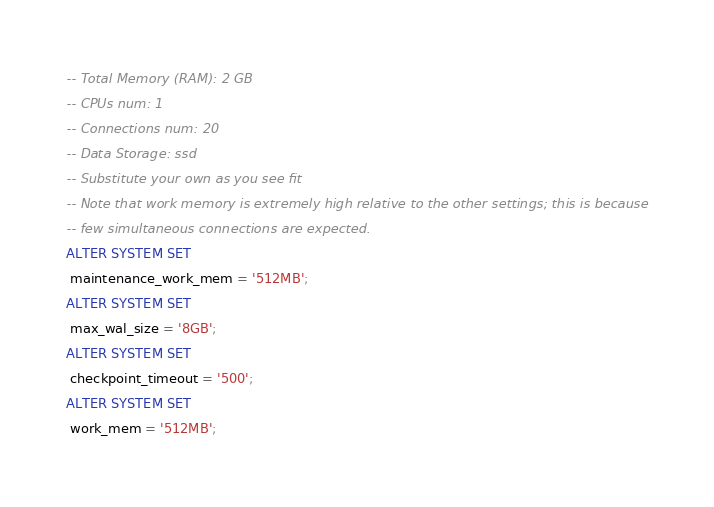<code> <loc_0><loc_0><loc_500><loc_500><_SQL_>-- Total Memory (RAM): 2 GB
-- CPUs num: 1
-- Connections num: 20
-- Data Storage: ssd
-- Substitute your own as you see fit
-- Note that work memory is extremely high relative to the other settings; this is because
-- few simultaneous connections are expected.
ALTER SYSTEM SET
 maintenance_work_mem = '512MB';
ALTER SYSTEM SET
 max_wal_size = '8GB';
ALTER SYSTEM SET
 checkpoint_timeout = '500';
ALTER SYSTEM SET
 work_mem = '512MB';</code> 